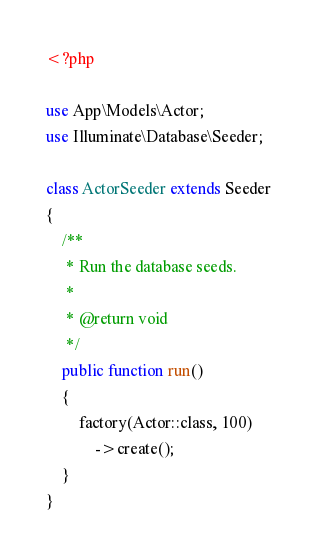Convert code to text. <code><loc_0><loc_0><loc_500><loc_500><_PHP_><?php

use App\Models\Actor;
use Illuminate\Database\Seeder;

class ActorSeeder extends Seeder
{
    /**
     * Run the database seeds.
     *
     * @return void
     */
    public function run()
    {
        factory(Actor::class, 100)
            ->create();
    }
}
</code> 